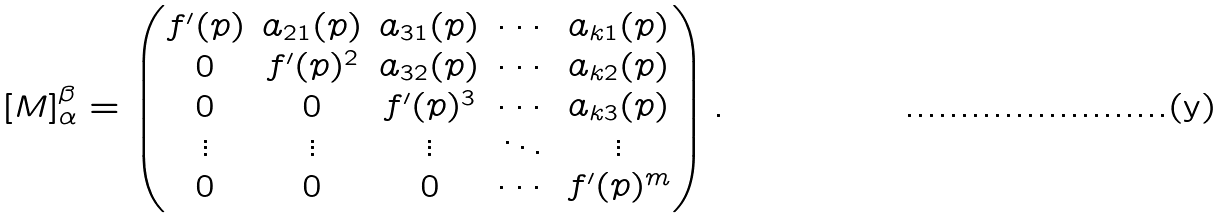<formula> <loc_0><loc_0><loc_500><loc_500>[ M ] _ { \alpha } ^ { \beta } = \begin{pmatrix} f ^ { \prime } ( p ) & a _ { 2 1 } ( p ) & a _ { 3 1 } ( p ) & \cdots & a _ { k 1 } ( p ) \\ 0 & f ^ { \prime } ( p ) ^ { 2 } & a _ { 3 2 } ( p ) & \cdots & a _ { k 2 } ( p ) \\ 0 & 0 & f ^ { \prime } ( p ) ^ { 3 } & \cdots & a _ { k 3 } ( p ) \\ \vdots & \vdots & \vdots & \ddots & \vdots \\ 0 & 0 & 0 & \cdots & f ^ { \prime } ( p ) ^ { m } \end{pmatrix} .</formula> 